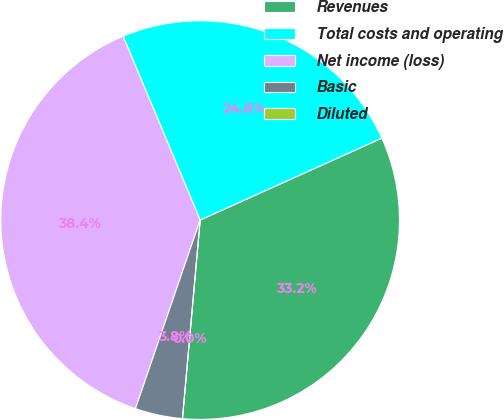Convert chart. <chart><loc_0><loc_0><loc_500><loc_500><pie_chart><fcel>Revenues<fcel>Total costs and operating<fcel>Net income (loss)<fcel>Basic<fcel>Diluted<nl><fcel>33.16%<fcel>24.57%<fcel>38.42%<fcel>3.84%<fcel>0.0%<nl></chart> 